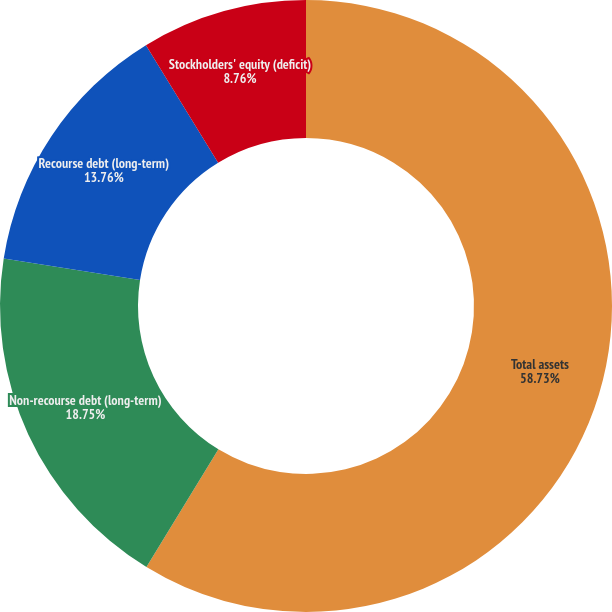Convert chart. <chart><loc_0><loc_0><loc_500><loc_500><pie_chart><fcel>Total assets<fcel>Non-recourse debt (long-term)<fcel>Recourse debt (long-term)<fcel>Stockholders' equity (deficit)<nl><fcel>58.73%<fcel>18.75%<fcel>13.76%<fcel>8.76%<nl></chart> 